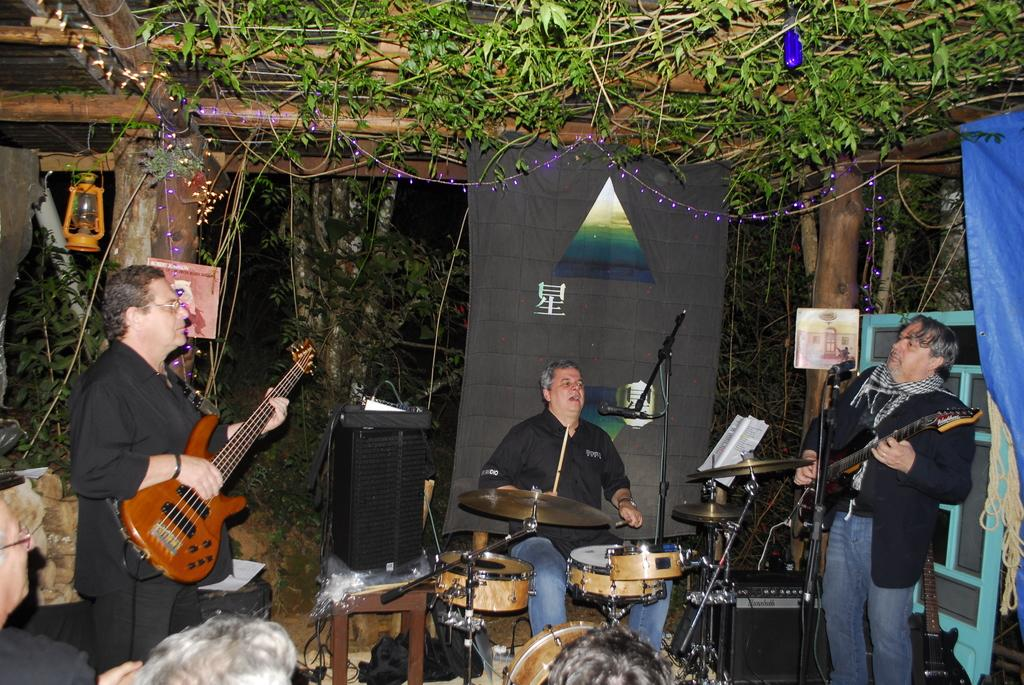Who or what can be seen in the image? There are people in the image. What are the people doing in the image? The people are playing musical instruments in the image. What can be seen on the left side of the image? There are lights on the left side of the image. What type of natural elements can be seen at the top of the image? Leaves are visible at the top of the image. What type of prose is being recited by the people in the image? There is no indication in the image that the people are reciting any prose; they are playing musical instruments. 